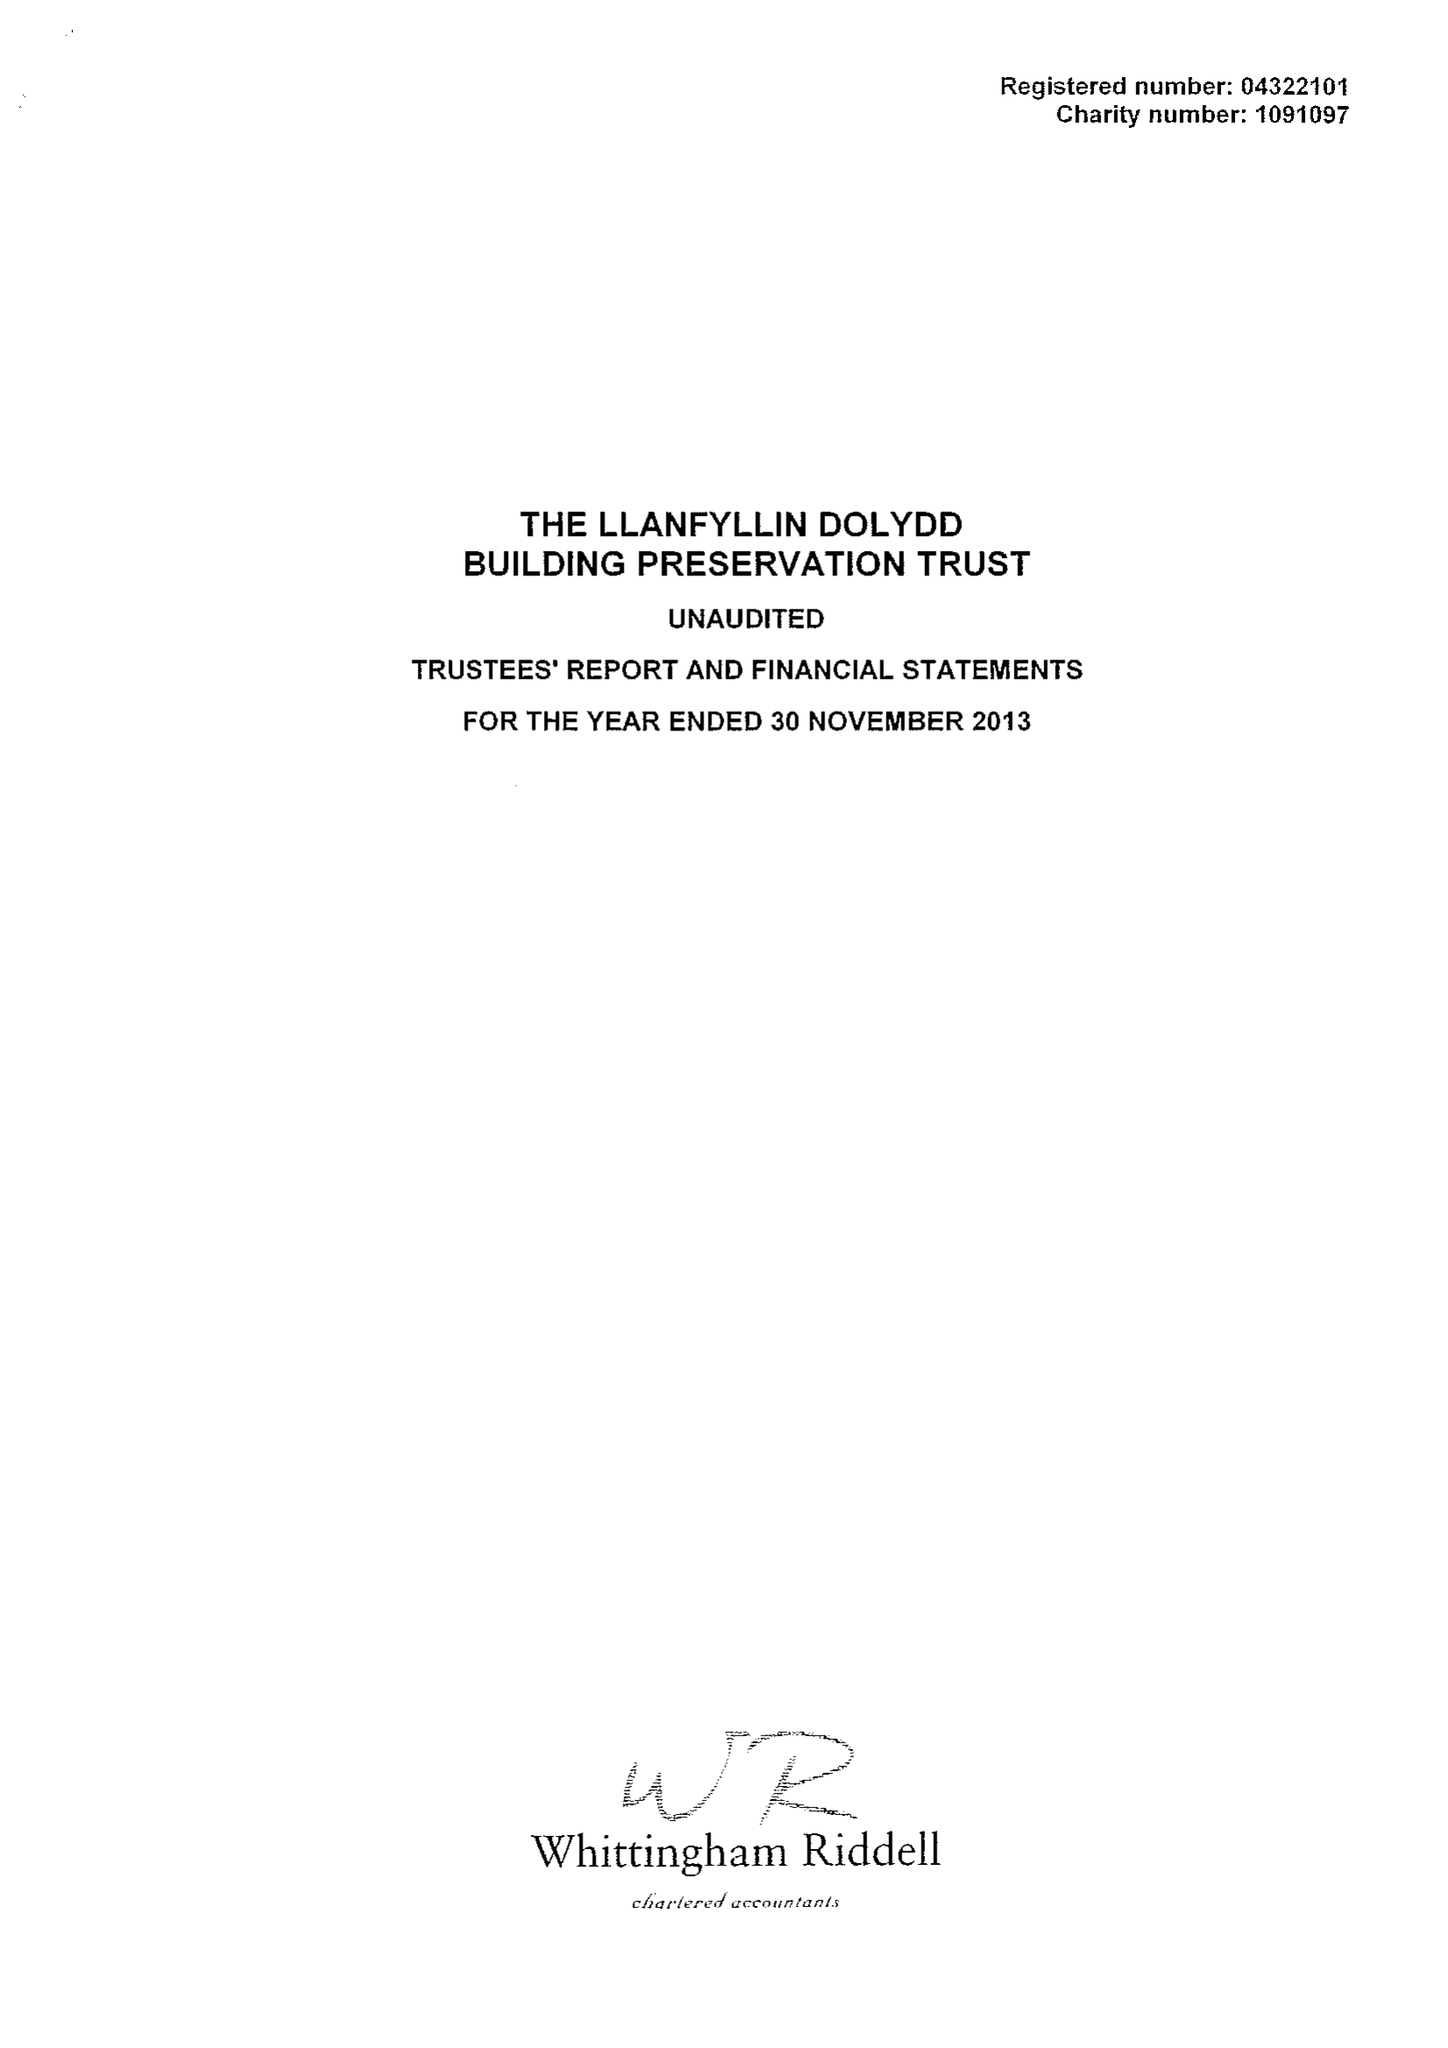What is the value for the income_annually_in_british_pounds?
Answer the question using a single word or phrase. 54716.00 